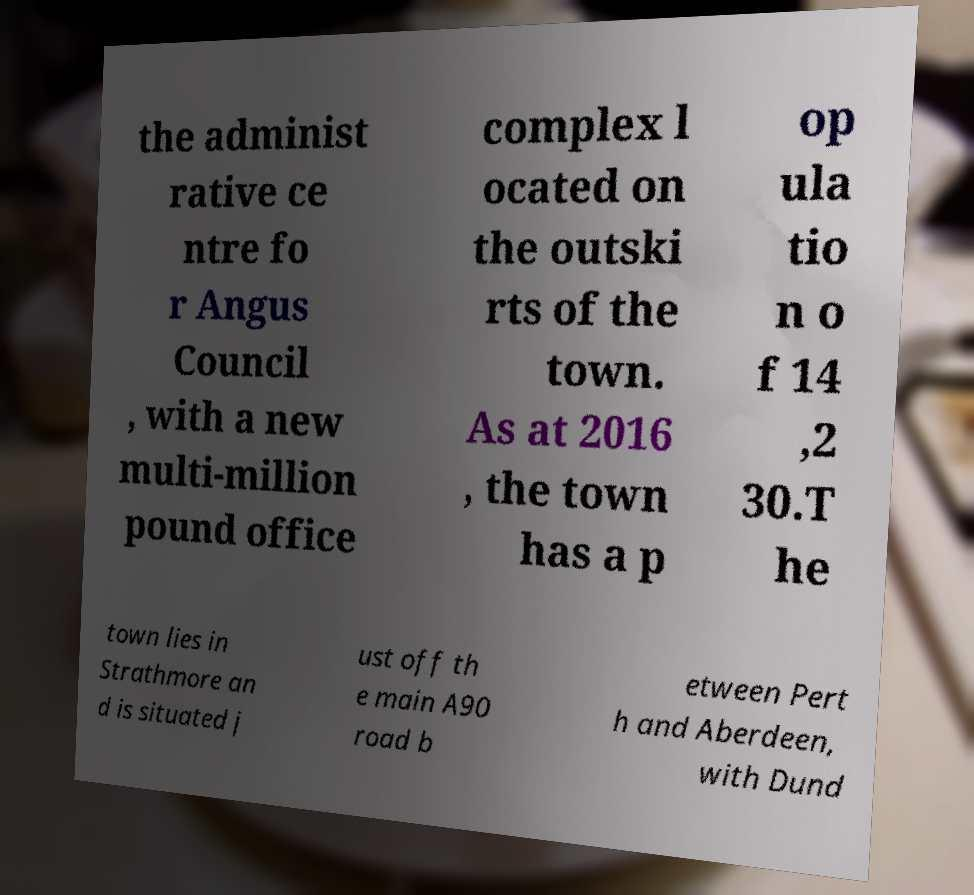Please read and relay the text visible in this image. What does it say? the administ rative ce ntre fo r Angus Council , with a new multi-million pound office complex l ocated on the outski rts of the town. As at 2016 , the town has a p op ula tio n o f 14 ,2 30.T he town lies in Strathmore an d is situated j ust off th e main A90 road b etween Pert h and Aberdeen, with Dund 